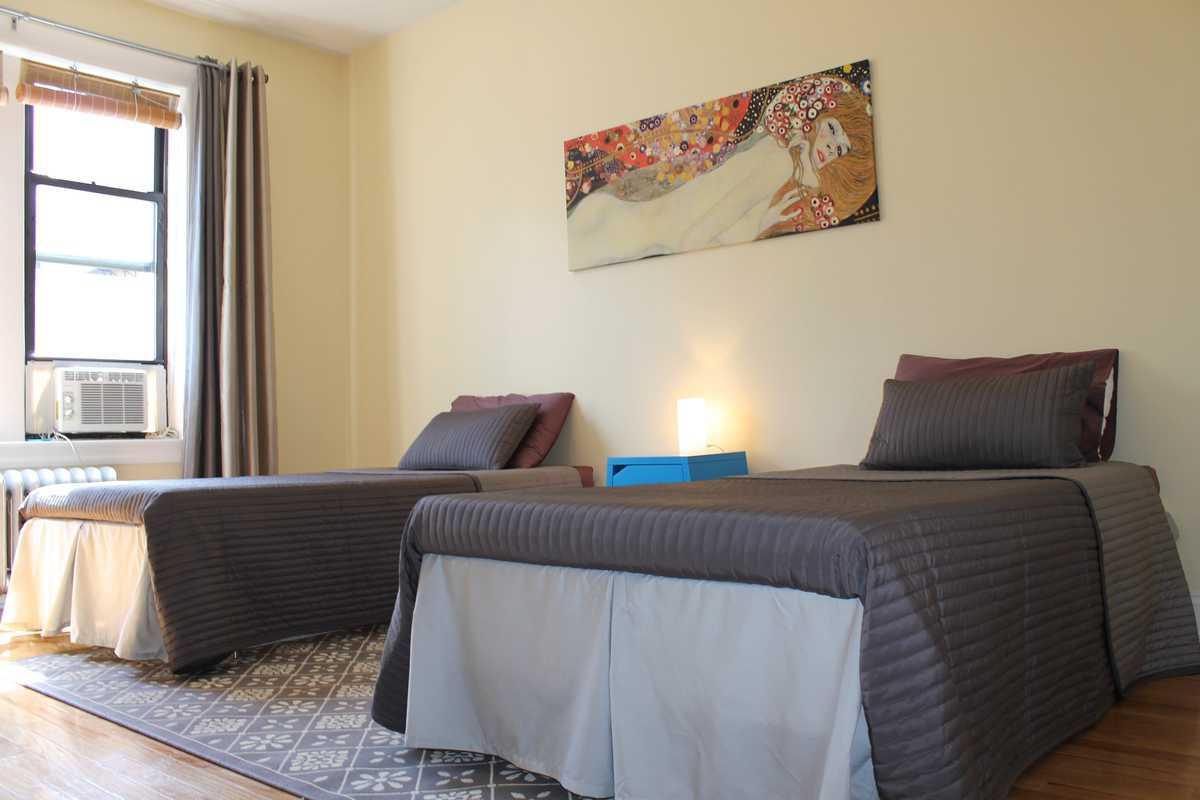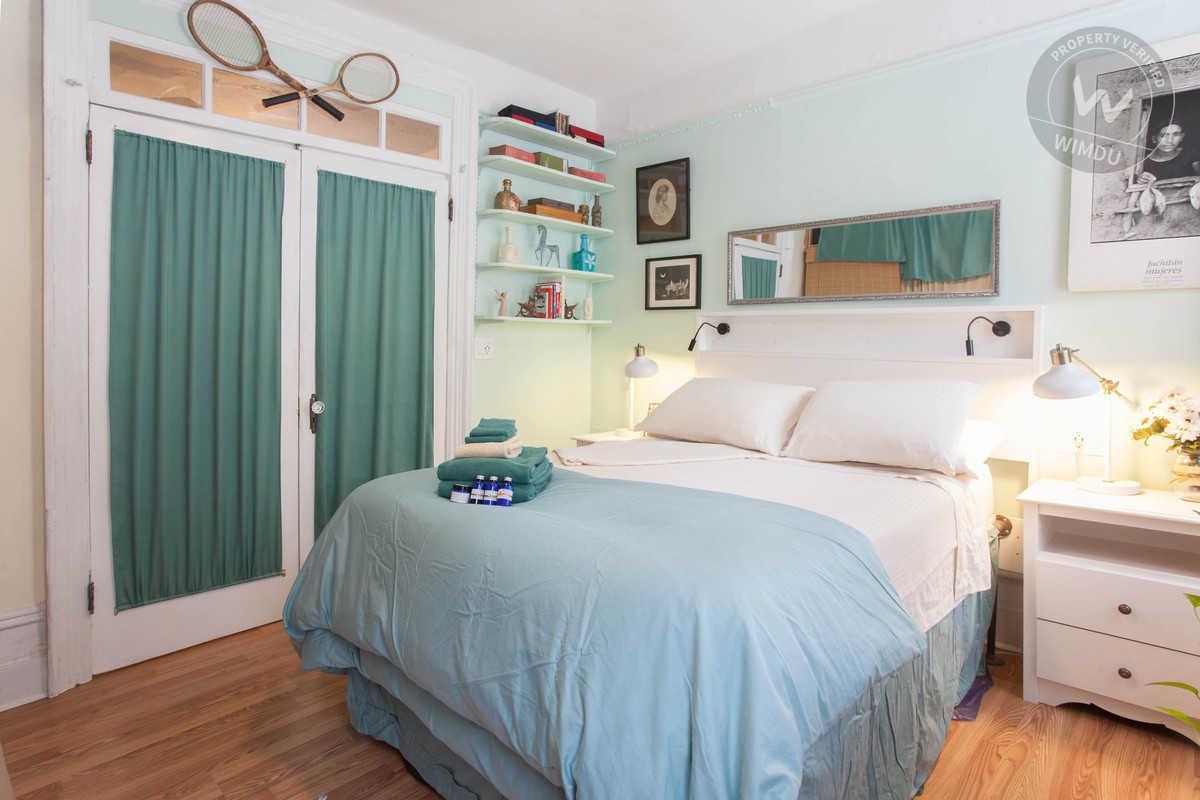The first image is the image on the left, the second image is the image on the right. Considering the images on both sides, is "One room has twin beds with gray bedding, and the other room contains one larger bed with white pillows." valid? Answer yes or no. Yes. The first image is the image on the left, the second image is the image on the right. Considering the images on both sides, is "there are two beds in a room with a picture of a woman on the wall and a blue table between them" valid? Answer yes or no. Yes. 